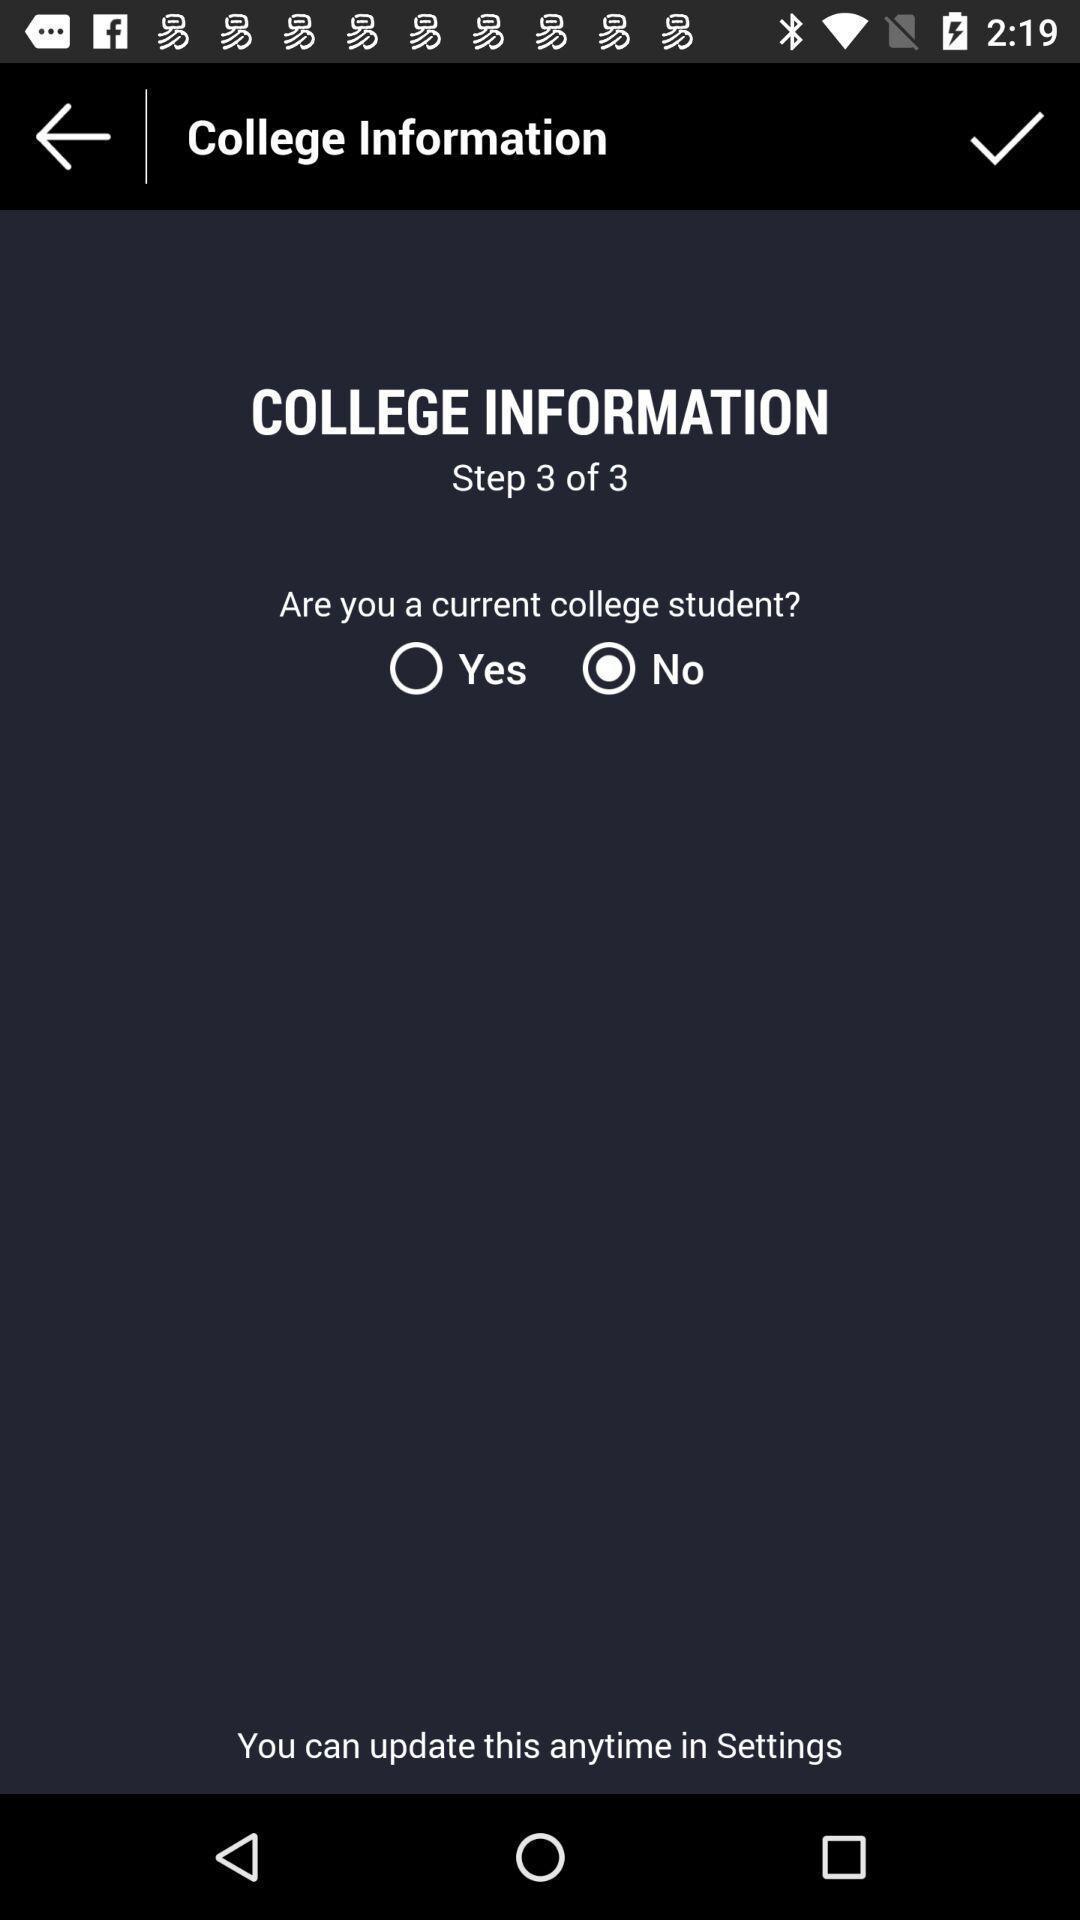Give me a narrative description of this picture. Page showing college information. 